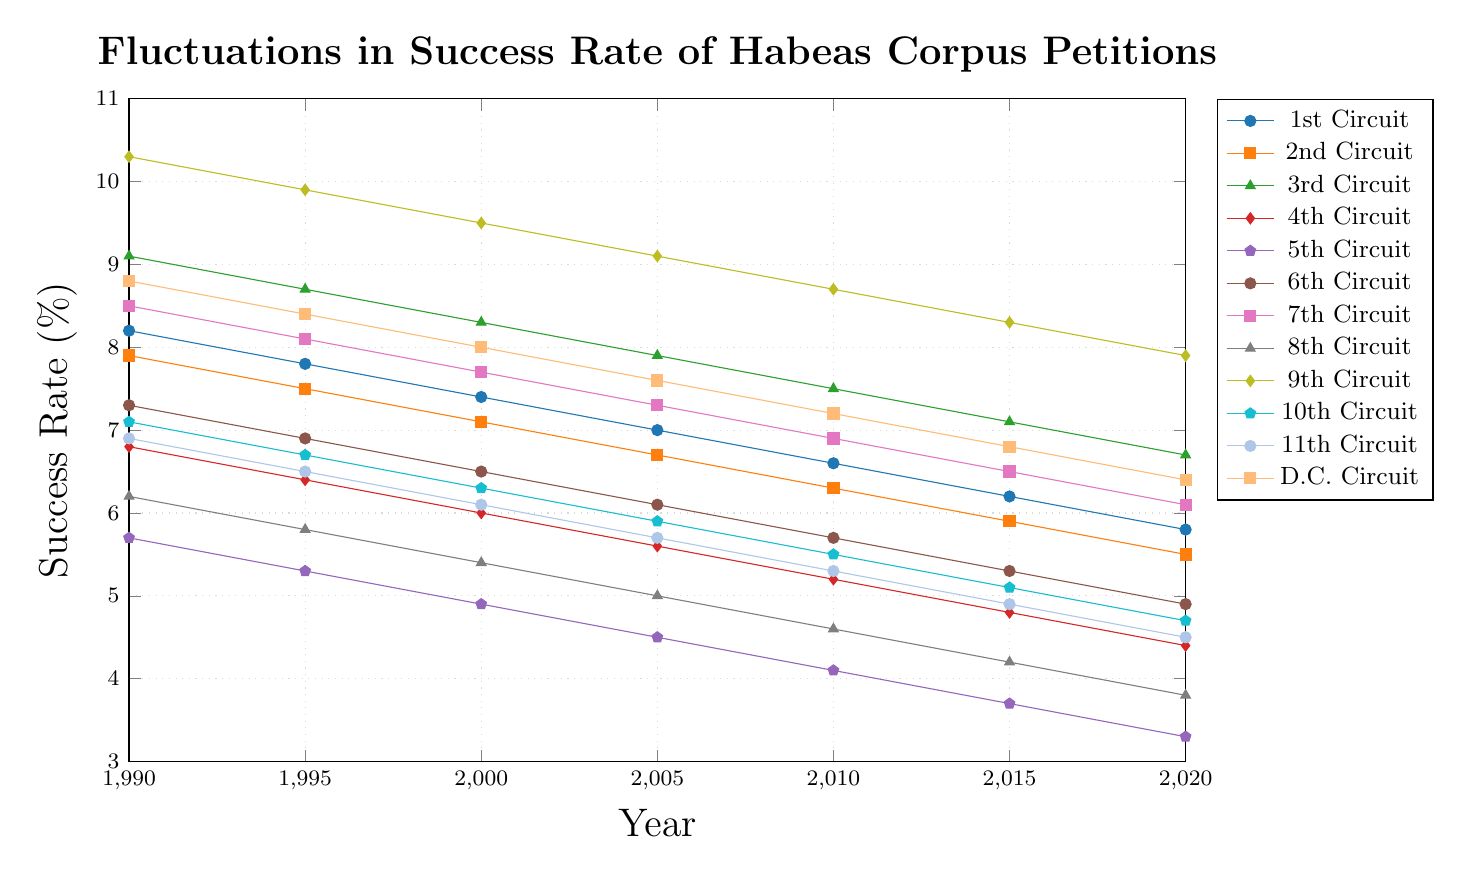Which circuit had the highest success rate of habeas corpus petitions in 1990? Look at the data points for the year 1990 and identify the highest value. The 9th Circuit has the highest success rate at 10.3%.
Answer: 9th Circuit Which circuits had a consistent downward trend in the success rates from 1990 to 2020? Identify the circuits whose line continuously decreases from 1990 to 2020 without any increases. The 4th, 5th, 6th, 8th, and 11th Circuits show a consistent downward trend.
Answer: 4th Circuit, 5th Circuit, 6th Circuit, 8th Circuit, 11th Circuit By how much did the success rate change for the 1st Circuit from 1990 to 2020? Subtract the success rate of the 1st Circuit in 2020 from its rate in 1990: 8.2% - 5.8%. The change is 2.4%.
Answer: 2.4% Which circuit experienced the smallest decrease in success rate from 1990 to 2020? Calculate the difference between 1990 and 2020 for each circuit and identify the smallest one. The 2nd Circuit changed by 2.4%, which is the smallest decrease among all circuits.
Answer: 2nd Circuit Which year had the highest overall success rate across all circuits? Compare the highest points of all lines for different years and identify the year with the highest single data point. The highest overall success rate is 10.3% in 1990 (9th Circuit).
Answer: 1990 Did any circuit ever exceed a 10% success rate? Identify if any of the data points exceed 10%. The 9th Circuit exceeded 10% with a 10.3% success rate in 1990.
Answer: Yes, 9th Circuit in 1990 Which circuit had the lowest success rate in 2020? Look at the data points for the year 2020 and identify the lowest value. The 5th Circuit had the lowest success rate at 3.3%.
Answer: 5th Circuit Which circuit had the most variation in its success rate from 1990 to 2020? Calculate the difference between the highest and lowest data points for each circuit and identify the largest one. The 1st Circuit had the largest variation, going from 8.2% in 1990 to 5.8% in 2020, a difference of 2.4%.
Answer: 1st Circuit 